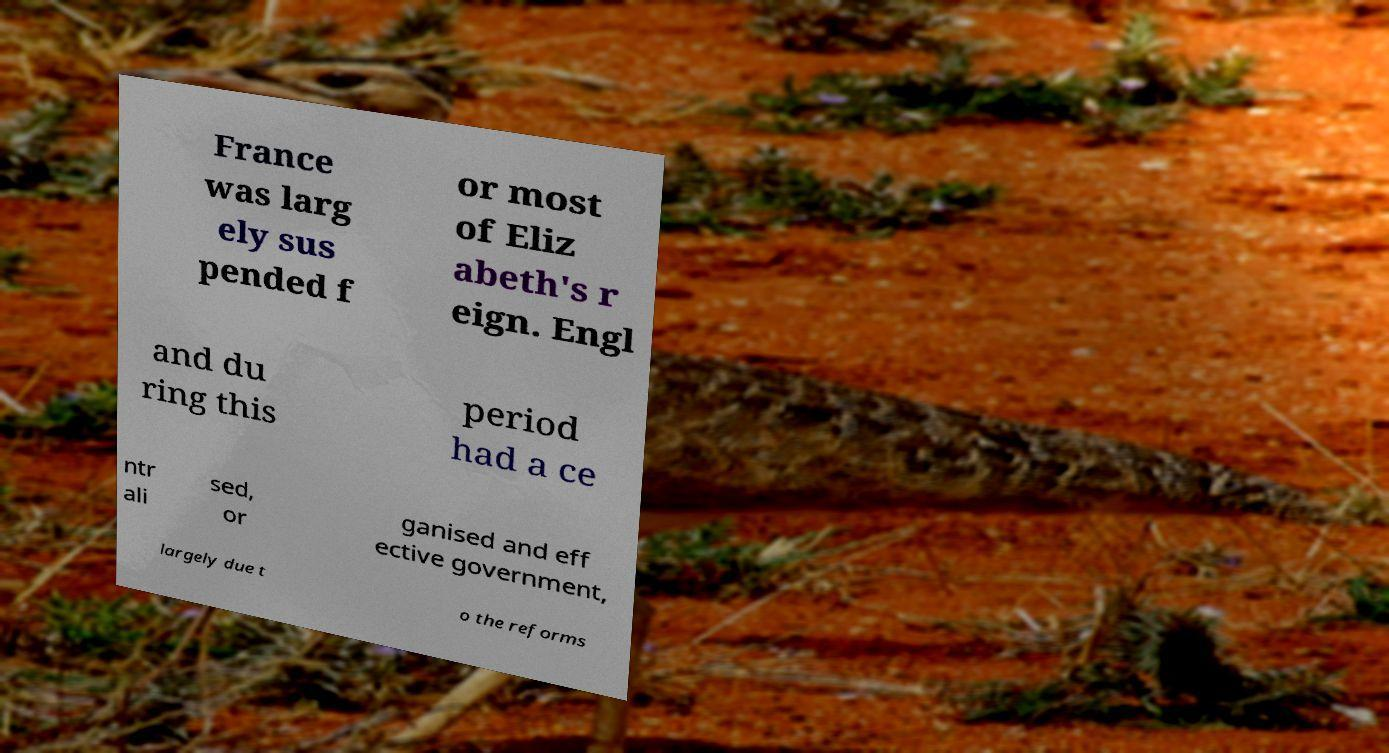Please read and relay the text visible in this image. What does it say? France was larg ely sus pended f or most of Eliz abeth's r eign. Engl and du ring this period had a ce ntr ali sed, or ganised and eff ective government, largely due t o the reforms 